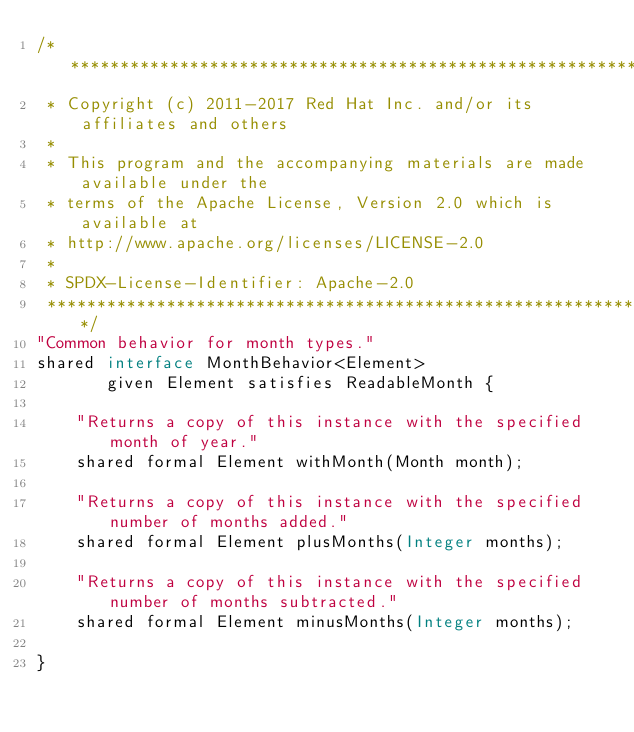Convert code to text. <code><loc_0><loc_0><loc_500><loc_500><_Ceylon_>/********************************************************************************
 * Copyright (c) 2011-2017 Red Hat Inc. and/or its affiliates and others
 *
 * This program and the accompanying materials are made available under the 
 * terms of the Apache License, Version 2.0 which is available at
 * http://www.apache.org/licenses/LICENSE-2.0
 *
 * SPDX-License-Identifier: Apache-2.0 
 ********************************************************************************/
"Common behavior for month types."
shared interface MonthBehavior<Element>
       given Element satisfies ReadableMonth {

    "Returns a copy of this instance with the specified month of year."
    shared formal Element withMonth(Month month);

    "Returns a copy of this instance with the specified number of months added."
    shared formal Element plusMonths(Integer months);

    "Returns a copy of this instance with the specified number of months subtracted."
    shared formal Element minusMonths(Integer months);

}</code> 